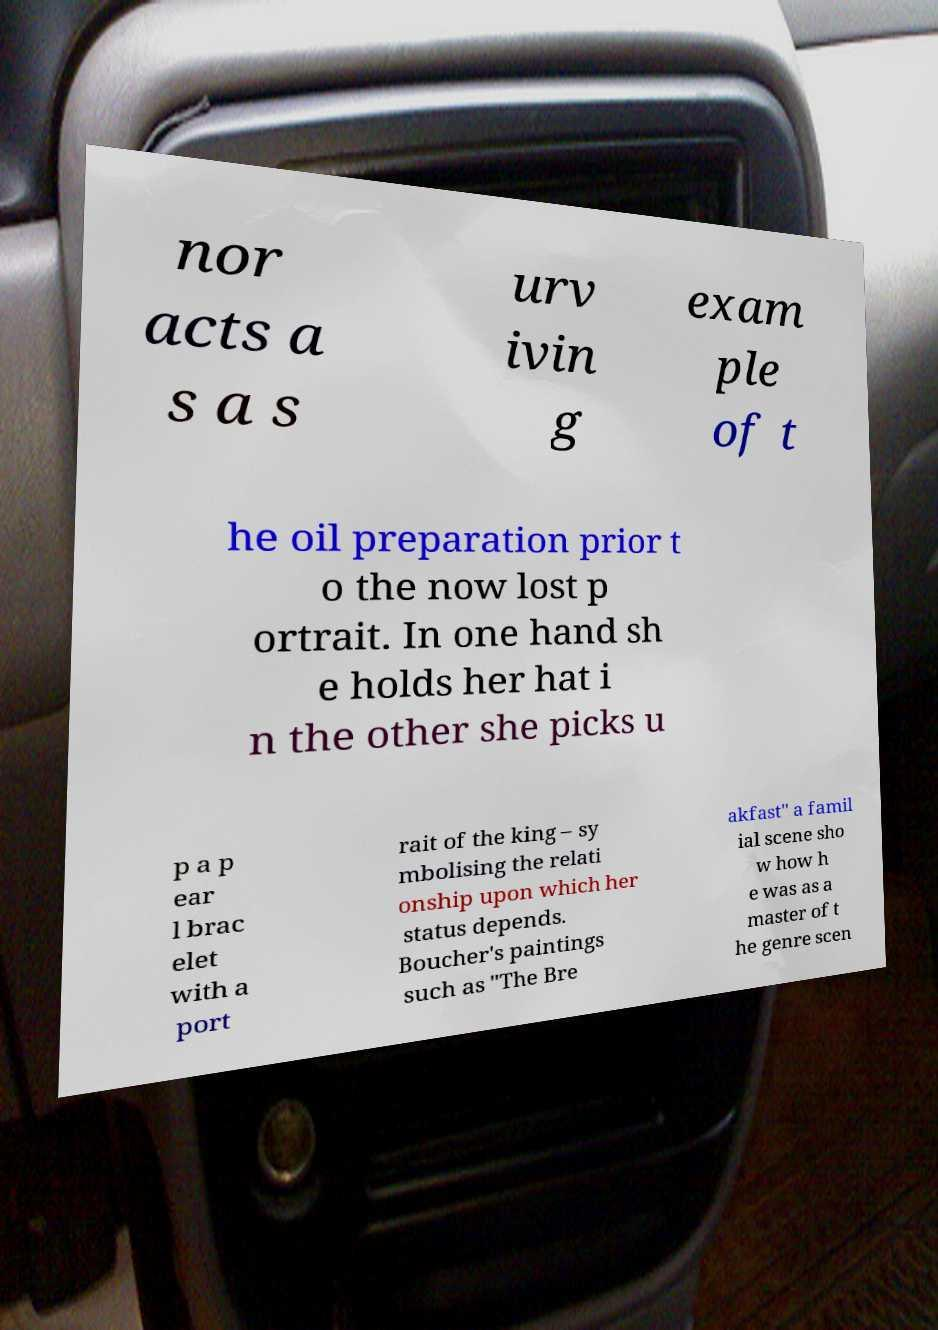Please identify and transcribe the text found in this image. nor acts a s a s urv ivin g exam ple of t he oil preparation prior t o the now lost p ortrait. In one hand sh e holds her hat i n the other she picks u p a p ear l brac elet with a port rait of the king – sy mbolising the relati onship upon which her status depends. Boucher's paintings such as "The Bre akfast" a famil ial scene sho w how h e was as a master of t he genre scen 